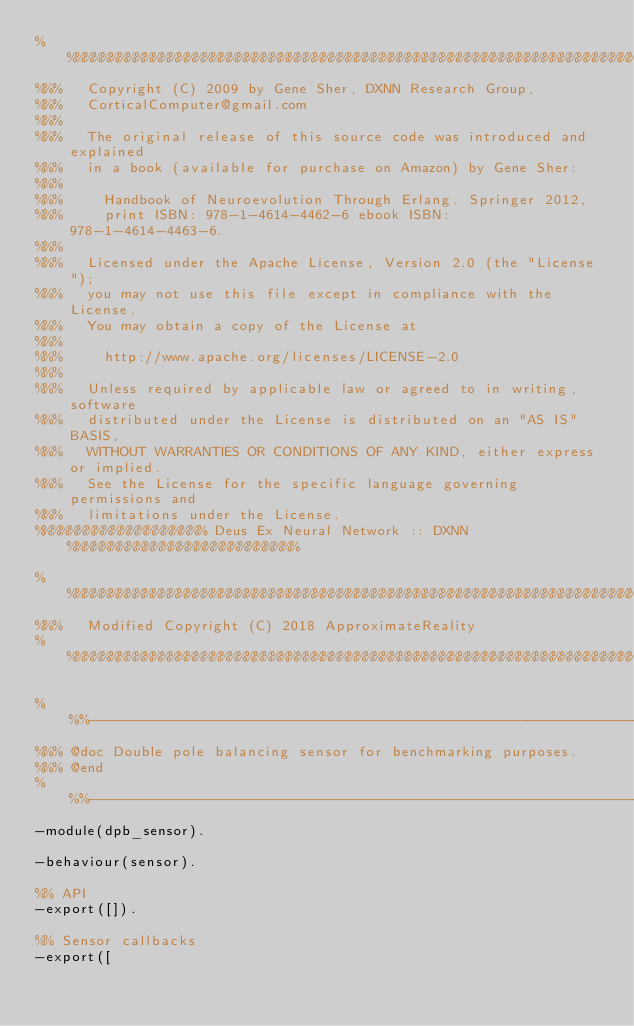Convert code to text. <code><loc_0><loc_0><loc_500><loc_500><_Erlang_>%%%%%%%%%%%%%%%%%%%%%%%%%%%%%%%%%%%%%%%%%%%%%%%%%%%%%%%%%%%%%%%%%%%%%%%%%%%%%%%
%%%   Copyright (C) 2009 by Gene Sher, DXNN Research Group,
%%%   CorticalComputer@gmail.com
%%%
%%%   The original release of this source code was introduced and explained
%%%   in a book (available for purchase on Amazon) by Gene Sher:
%%%     
%%%     Handbook of Neuroevolution Through Erlang. Springer 2012,
%%%     print ISBN: 978-1-4614-4462-6 ebook ISBN: 978-1-4614-4463-6.
%%% 
%%%   Licensed under the Apache License, Version 2.0 (the "License");
%%%   you may not use this file except in compliance with the License.
%%%   You may obtain a copy of the License at
%%%
%%%     http://www.apache.org/licenses/LICENSE-2.0
%%%
%%%   Unless required by applicable law or agreed to in writing, software
%%%   distributed under the License is distributed on an "AS IS" BASIS,
%%%   WITHOUT WARRANTIES OR CONDITIONS OF ANY KIND, either express or implied.
%%%   See the License for the specific language governing permissions and
%%%   limitations under the License.
%%%%%%%%%%%%%%%%%%%% Deus Ex Neural Network :: DXNN %%%%%%%%%%%%%%%%%%%%%%%%%%%

%%%%%%%%%%%%%%%%%%%%%%%%%%%%%%%%%%%%%%%%%%%%%%%%%%%%%%%%%%%%%%%%%%%%%%%%%%%%%%%
%%%   Modified Copyright (C) 2018 ApproximateReality
%%%%%%%%%%%%%%%%%%%%%%%%%%%%%%%%%%%%%%%%%%%%%%%%%%%%%%%%%%%%%%%%%%%%%%%%%%%%%%%

%%%----------------------------------------------------------------------------
%%% @doc Double pole balancing sensor for benchmarking purposes.
%%% @end
%%%----------------------------------------------------------------------------
-module(dpb_sensor).

-behaviour(sensor).

%% API
-export([]).

%% Sensor callbacks
-export([</code> 